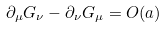<formula> <loc_0><loc_0><loc_500><loc_500>\partial _ { \mu } G _ { \nu } - \partial _ { \nu } G _ { \mu } = O ( a )</formula> 